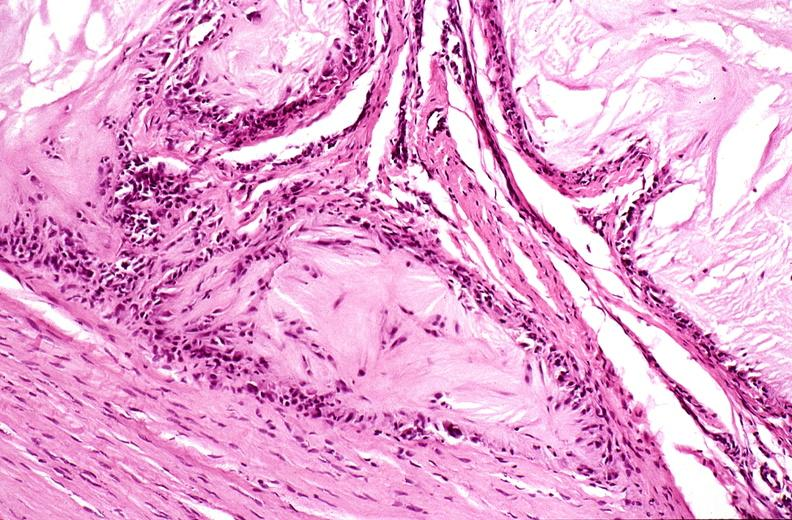s mitotic figures present?
Answer the question using a single word or phrase. No 